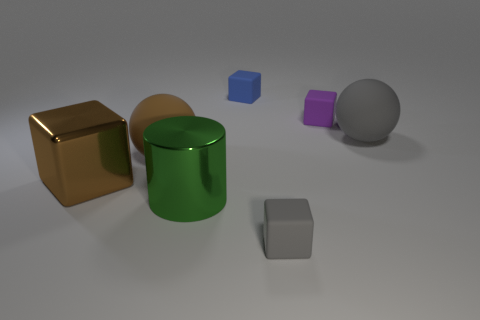What color is the rubber cube that is in front of the block that is to the left of the thing behind the purple block?
Provide a succinct answer. Gray. The big object that is the same shape as the tiny gray rubber thing is what color?
Provide a succinct answer. Brown. Is there any other thing that is the same color as the large cylinder?
Your response must be concise. No. What number of other objects are the same material as the large brown ball?
Keep it short and to the point. 4. The purple object is what size?
Your response must be concise. Small. Are there any tiny gray matte objects that have the same shape as the big gray object?
Offer a terse response. No. How many objects are either red spheres or matte cubes in front of the brown metallic object?
Offer a terse response. 1. The metallic object behind the large green metal thing is what color?
Ensure brevity in your answer.  Brown. Is the size of the sphere right of the large metallic cylinder the same as the gray rubber object that is in front of the brown shiny object?
Keep it short and to the point. No. Are there any green metal things of the same size as the purple cube?
Your answer should be very brief. No. 